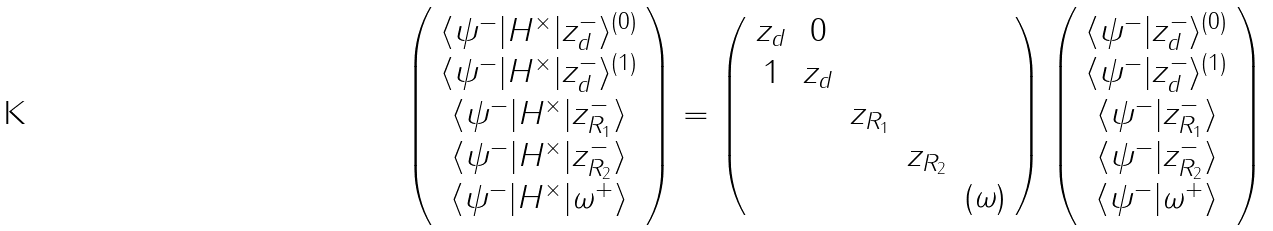Convert formula to latex. <formula><loc_0><loc_0><loc_500><loc_500>\left ( \begin{array} { c } \langle \psi ^ { - } | H ^ { \times } | z _ { d } ^ { - } \rangle ^ { ( 0 ) } \\ \langle \psi ^ { - } | H ^ { \times } | z _ { d } ^ { - } \rangle ^ { ( 1 ) } \\ \langle \psi ^ { - } | H ^ { \times } | z _ { R _ { 1 } } ^ { - } \rangle \\ \langle \psi ^ { - } | H ^ { \times } | z _ { R _ { 2 } } ^ { - } \rangle \\ \langle \psi ^ { - } | H ^ { \times } | \omega ^ { + } \rangle \end{array} \right ) = \left ( \begin{array} { c c c c c } z _ { d } & 0 \\ 1 & z _ { d } \\ & & z _ { R _ { 1 } } \\ & & & z _ { R _ { 2 } } \\ & & & & ( \omega ) \\ \end{array} \right ) \left ( \begin{array} { c } \langle \psi ^ { - } | z _ { d } ^ { - } \rangle ^ { ( 0 ) } \\ \langle \psi ^ { - } | z _ { d } ^ { - } \rangle ^ { ( 1 ) } \\ \langle \psi ^ { - } | z _ { R _ { 1 } } ^ { - } \rangle \\ \langle \psi ^ { - } | z _ { R _ { 2 } } ^ { - } \rangle \\ \langle \psi ^ { - } | \omega ^ { + } \rangle \end{array} \right )</formula> 